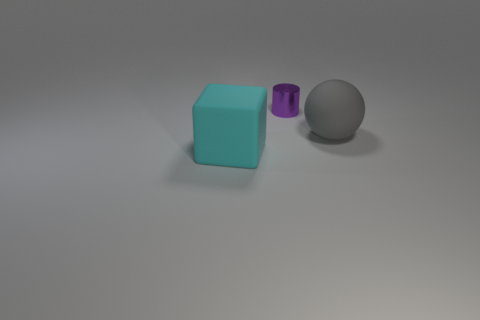The thing behind the big gray rubber thing has what shape? The object behind the large gray rubber-like item is shaped like a cylinder. It's a purple translucent object with a circular base, which tapers slightly towards the top, characteristic of a cylindrical form. 